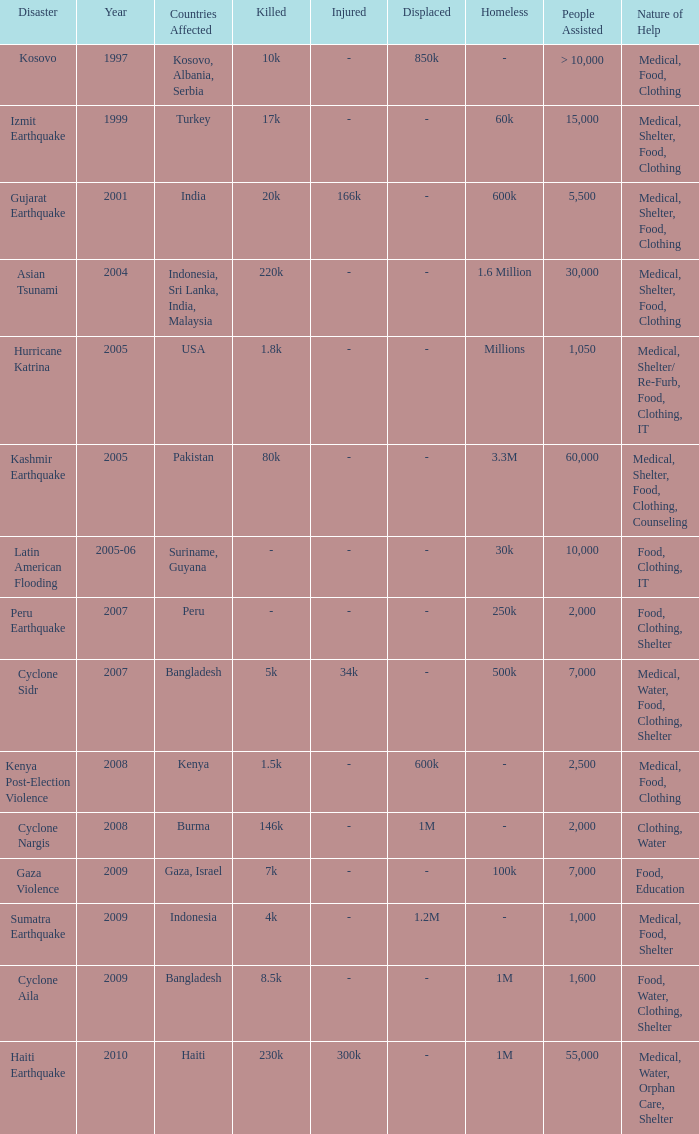In what year did the usa experience a catastrophe? 2005.0. 